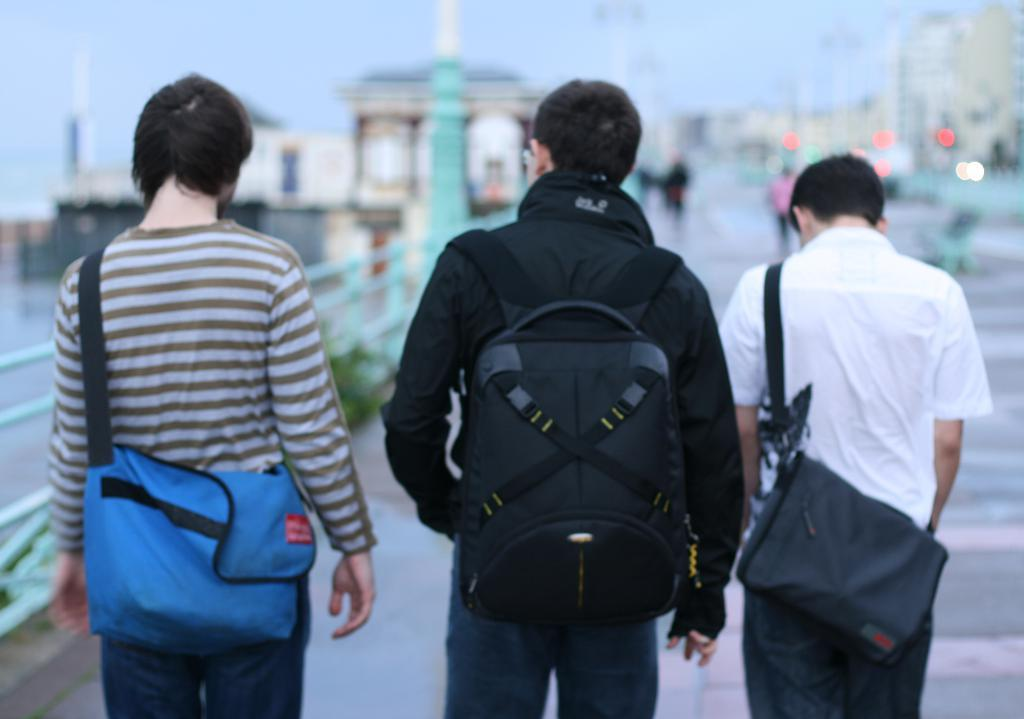How many men are present in the image? There are three men in the image. What are the men carrying? Each man is carrying a bag. Can you describe the presence of other people in the image? There are people visible in the image. What can be seen in the background of the image? There is a path in the image, although it appears blurred. What type of humor can be seen in the image? There is no humor present in the image; it is a straightforward depiction of three men carrying bags. 